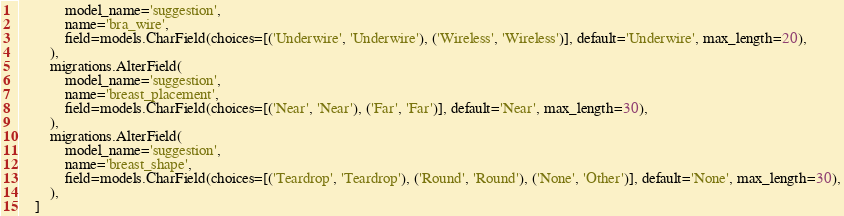Convert code to text. <code><loc_0><loc_0><loc_500><loc_500><_Python_>            model_name='suggestion',
            name='bra_wire',
            field=models.CharField(choices=[('Underwire', 'Underwire'), ('Wireless', 'Wireless')], default='Underwire', max_length=20),
        ),
        migrations.AlterField(
            model_name='suggestion',
            name='breast_placement',
            field=models.CharField(choices=[('Near', 'Near'), ('Far', 'Far')], default='Near', max_length=30),
        ),
        migrations.AlterField(
            model_name='suggestion',
            name='breast_shape',
            field=models.CharField(choices=[('Teardrop', 'Teardrop'), ('Round', 'Round'), ('None', 'Other')], default='None', max_length=30),
        ),
    ]
</code> 